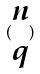Convert formula to latex. <formula><loc_0><loc_0><loc_500><loc_500>( \begin{matrix} n \\ q \end{matrix} )</formula> 